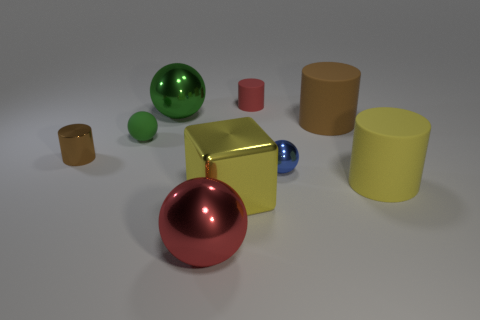What size is the object that is the same color as the rubber ball?
Ensure brevity in your answer.  Large. There is a big brown thing that is the same material as the tiny red object; what is its shape?
Your answer should be compact. Cylinder. Is there any other thing that has the same color as the small metallic ball?
Offer a terse response. No. How many small spheres are there?
Make the answer very short. 2. What is the sphere in front of the big yellow thing that is in front of the yellow cylinder made of?
Your response must be concise. Metal. There is a big shiny object that is behind the tiny thing that is right of the red thing on the right side of the large metallic cube; what color is it?
Your answer should be very brief. Green. Is the metal cube the same color as the tiny metal sphere?
Give a very brief answer. No. How many purple metal objects are the same size as the green rubber thing?
Provide a succinct answer. 0. Are there more metallic objects in front of the tiny metal cylinder than big red things left of the small green rubber object?
Offer a terse response. Yes. What is the color of the big rubber thing in front of the tiny metallic ball that is right of the tiny green ball?
Offer a terse response. Yellow. 